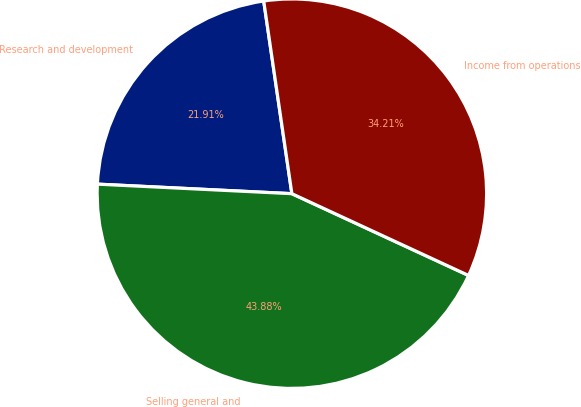<chart> <loc_0><loc_0><loc_500><loc_500><pie_chart><fcel>Research and development<fcel>Selling general and<fcel>Income from operations<nl><fcel>21.91%<fcel>43.88%<fcel>34.21%<nl></chart> 